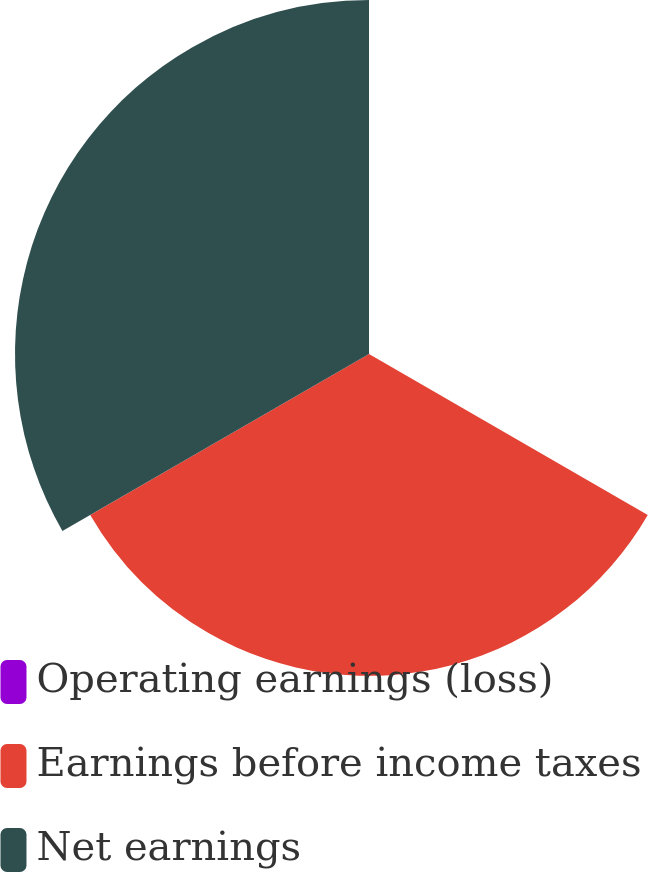Convert chart to OTSL. <chart><loc_0><loc_0><loc_500><loc_500><pie_chart><fcel>Operating earnings (loss)<fcel>Earnings before income taxes<fcel>Net earnings<nl><fcel>0.06%<fcel>47.59%<fcel>52.34%<nl></chart> 